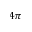Convert formula to latex. <formula><loc_0><loc_0><loc_500><loc_500>4 \pi</formula> 